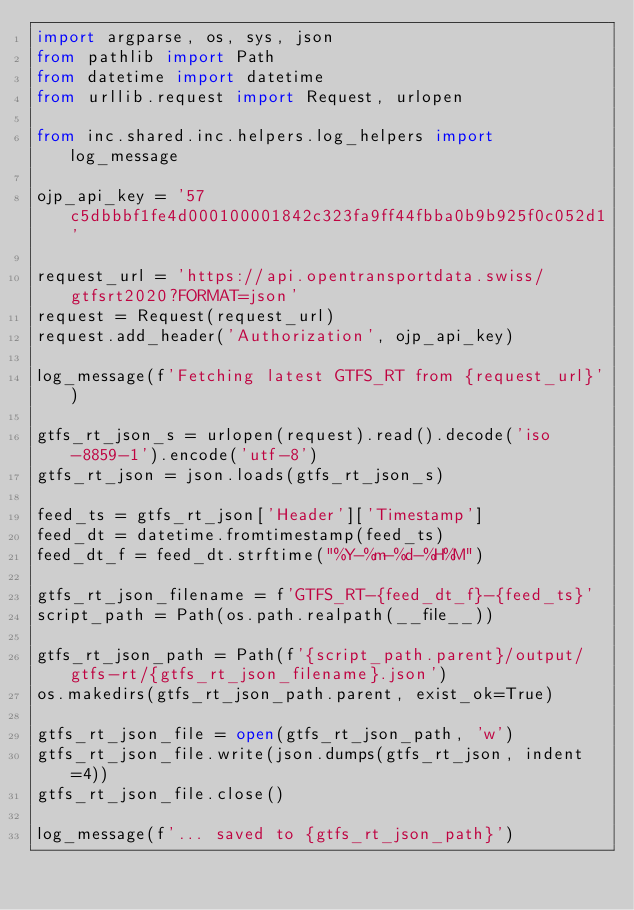<code> <loc_0><loc_0><loc_500><loc_500><_Python_>import argparse, os, sys, json
from pathlib import Path
from datetime import datetime
from urllib.request import Request, urlopen

from inc.shared.inc.helpers.log_helpers import log_message

ojp_api_key = '57c5dbbbf1fe4d000100001842c323fa9ff44fbba0b9b925f0c052d1'

request_url = 'https://api.opentransportdata.swiss/gtfsrt2020?FORMAT=json'
request = Request(request_url)
request.add_header('Authorization', ojp_api_key)

log_message(f'Fetching latest GTFS_RT from {request_url}')

gtfs_rt_json_s = urlopen(request).read().decode('iso-8859-1').encode('utf-8')
gtfs_rt_json = json.loads(gtfs_rt_json_s)

feed_ts = gtfs_rt_json['Header']['Timestamp']
feed_dt = datetime.fromtimestamp(feed_ts)
feed_dt_f = feed_dt.strftime("%Y-%m-%d-%H%M")

gtfs_rt_json_filename = f'GTFS_RT-{feed_dt_f}-{feed_ts}'
script_path = Path(os.path.realpath(__file__))

gtfs_rt_json_path = Path(f'{script_path.parent}/output/gtfs-rt/{gtfs_rt_json_filename}.json')
os.makedirs(gtfs_rt_json_path.parent, exist_ok=True)

gtfs_rt_json_file = open(gtfs_rt_json_path, 'w')
gtfs_rt_json_file.write(json.dumps(gtfs_rt_json, indent=4))
gtfs_rt_json_file.close()

log_message(f'... saved to {gtfs_rt_json_path}')</code> 